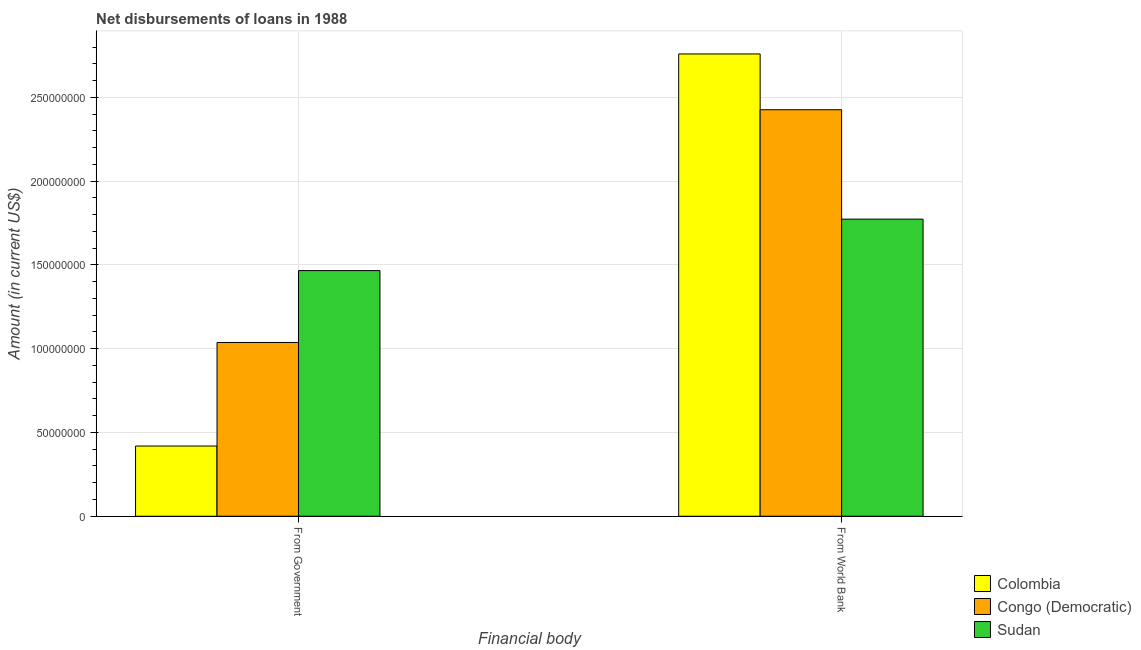Are the number of bars per tick equal to the number of legend labels?
Your answer should be very brief. Yes. Are the number of bars on each tick of the X-axis equal?
Offer a very short reply. Yes. How many bars are there on the 1st tick from the left?
Your answer should be very brief. 3. What is the label of the 1st group of bars from the left?
Provide a short and direct response. From Government. What is the net disbursements of loan from government in Sudan?
Offer a very short reply. 1.47e+08. Across all countries, what is the maximum net disbursements of loan from government?
Ensure brevity in your answer.  1.47e+08. Across all countries, what is the minimum net disbursements of loan from world bank?
Ensure brevity in your answer.  1.77e+08. In which country was the net disbursements of loan from government maximum?
Your response must be concise. Sudan. What is the total net disbursements of loan from government in the graph?
Your response must be concise. 2.92e+08. What is the difference between the net disbursements of loan from world bank in Colombia and that in Sudan?
Offer a terse response. 9.86e+07. What is the difference between the net disbursements of loan from world bank in Sudan and the net disbursements of loan from government in Colombia?
Keep it short and to the point. 1.35e+08. What is the average net disbursements of loan from world bank per country?
Give a very brief answer. 2.32e+08. What is the difference between the net disbursements of loan from world bank and net disbursements of loan from government in Colombia?
Provide a short and direct response. 2.34e+08. What is the ratio of the net disbursements of loan from world bank in Sudan to that in Congo (Democratic)?
Provide a short and direct response. 0.73. Is the net disbursements of loan from world bank in Colombia less than that in Sudan?
Ensure brevity in your answer.  No. In how many countries, is the net disbursements of loan from government greater than the average net disbursements of loan from government taken over all countries?
Give a very brief answer. 2. What does the 3rd bar from the left in From World Bank represents?
Give a very brief answer. Sudan. What does the 1st bar from the right in From World Bank represents?
Ensure brevity in your answer.  Sudan. How many bars are there?
Make the answer very short. 6. Are all the bars in the graph horizontal?
Your answer should be compact. No. How many countries are there in the graph?
Ensure brevity in your answer.  3. What is the difference between two consecutive major ticks on the Y-axis?
Offer a very short reply. 5.00e+07. Are the values on the major ticks of Y-axis written in scientific E-notation?
Provide a short and direct response. No. Does the graph contain grids?
Ensure brevity in your answer.  Yes. How many legend labels are there?
Your response must be concise. 3. What is the title of the graph?
Offer a terse response. Net disbursements of loans in 1988. Does "South Africa" appear as one of the legend labels in the graph?
Give a very brief answer. No. What is the label or title of the X-axis?
Ensure brevity in your answer.  Financial body. What is the Amount (in current US$) of Colombia in From Government?
Make the answer very short. 4.19e+07. What is the Amount (in current US$) of Congo (Democratic) in From Government?
Your answer should be compact. 1.04e+08. What is the Amount (in current US$) in Sudan in From Government?
Give a very brief answer. 1.47e+08. What is the Amount (in current US$) in Colombia in From World Bank?
Your answer should be very brief. 2.76e+08. What is the Amount (in current US$) in Congo (Democratic) in From World Bank?
Provide a short and direct response. 2.43e+08. What is the Amount (in current US$) of Sudan in From World Bank?
Provide a short and direct response. 1.77e+08. Across all Financial body, what is the maximum Amount (in current US$) of Colombia?
Provide a succinct answer. 2.76e+08. Across all Financial body, what is the maximum Amount (in current US$) of Congo (Democratic)?
Give a very brief answer. 2.43e+08. Across all Financial body, what is the maximum Amount (in current US$) of Sudan?
Your answer should be very brief. 1.77e+08. Across all Financial body, what is the minimum Amount (in current US$) in Colombia?
Offer a very short reply. 4.19e+07. Across all Financial body, what is the minimum Amount (in current US$) of Congo (Democratic)?
Make the answer very short. 1.04e+08. Across all Financial body, what is the minimum Amount (in current US$) of Sudan?
Offer a terse response. 1.47e+08. What is the total Amount (in current US$) of Colombia in the graph?
Your answer should be very brief. 3.18e+08. What is the total Amount (in current US$) of Congo (Democratic) in the graph?
Ensure brevity in your answer.  3.46e+08. What is the total Amount (in current US$) in Sudan in the graph?
Ensure brevity in your answer.  3.24e+08. What is the difference between the Amount (in current US$) in Colombia in From Government and that in From World Bank?
Provide a short and direct response. -2.34e+08. What is the difference between the Amount (in current US$) of Congo (Democratic) in From Government and that in From World Bank?
Ensure brevity in your answer.  -1.39e+08. What is the difference between the Amount (in current US$) in Sudan in From Government and that in From World Bank?
Give a very brief answer. -3.07e+07. What is the difference between the Amount (in current US$) in Colombia in From Government and the Amount (in current US$) in Congo (Democratic) in From World Bank?
Offer a terse response. -2.01e+08. What is the difference between the Amount (in current US$) in Colombia in From Government and the Amount (in current US$) in Sudan in From World Bank?
Offer a very short reply. -1.35e+08. What is the difference between the Amount (in current US$) in Congo (Democratic) in From Government and the Amount (in current US$) in Sudan in From World Bank?
Keep it short and to the point. -7.36e+07. What is the average Amount (in current US$) in Colombia per Financial body?
Offer a terse response. 1.59e+08. What is the average Amount (in current US$) of Congo (Democratic) per Financial body?
Provide a short and direct response. 1.73e+08. What is the average Amount (in current US$) in Sudan per Financial body?
Keep it short and to the point. 1.62e+08. What is the difference between the Amount (in current US$) in Colombia and Amount (in current US$) in Congo (Democratic) in From Government?
Keep it short and to the point. -6.18e+07. What is the difference between the Amount (in current US$) in Colombia and Amount (in current US$) in Sudan in From Government?
Offer a terse response. -1.05e+08. What is the difference between the Amount (in current US$) in Congo (Democratic) and Amount (in current US$) in Sudan in From Government?
Give a very brief answer. -4.29e+07. What is the difference between the Amount (in current US$) in Colombia and Amount (in current US$) in Congo (Democratic) in From World Bank?
Make the answer very short. 3.33e+07. What is the difference between the Amount (in current US$) in Colombia and Amount (in current US$) in Sudan in From World Bank?
Give a very brief answer. 9.86e+07. What is the difference between the Amount (in current US$) in Congo (Democratic) and Amount (in current US$) in Sudan in From World Bank?
Offer a very short reply. 6.53e+07. What is the ratio of the Amount (in current US$) of Colombia in From Government to that in From World Bank?
Your response must be concise. 0.15. What is the ratio of the Amount (in current US$) in Congo (Democratic) in From Government to that in From World Bank?
Provide a short and direct response. 0.43. What is the ratio of the Amount (in current US$) in Sudan in From Government to that in From World Bank?
Your response must be concise. 0.83. What is the difference between the highest and the second highest Amount (in current US$) of Colombia?
Provide a succinct answer. 2.34e+08. What is the difference between the highest and the second highest Amount (in current US$) of Congo (Democratic)?
Ensure brevity in your answer.  1.39e+08. What is the difference between the highest and the second highest Amount (in current US$) in Sudan?
Provide a succinct answer. 3.07e+07. What is the difference between the highest and the lowest Amount (in current US$) in Colombia?
Provide a succinct answer. 2.34e+08. What is the difference between the highest and the lowest Amount (in current US$) in Congo (Democratic)?
Offer a very short reply. 1.39e+08. What is the difference between the highest and the lowest Amount (in current US$) of Sudan?
Ensure brevity in your answer.  3.07e+07. 